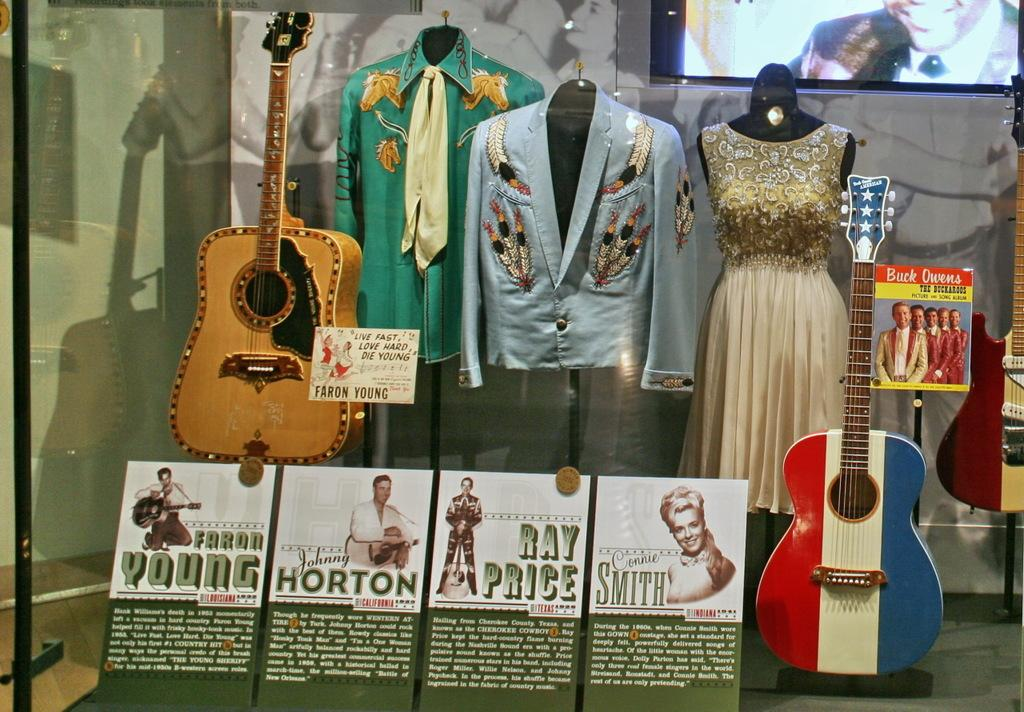What object is present in the image? There is a glass in the image. What is inside the glass? There are guitars, clothes, and a screen inside the glass. Can you observe a crow perched on the guitars inside the glass? There is no crow present in the image; it only features a glass with guitars, clothes, and a screen inside. 